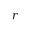<formula> <loc_0><loc_0><loc_500><loc_500>r</formula> 